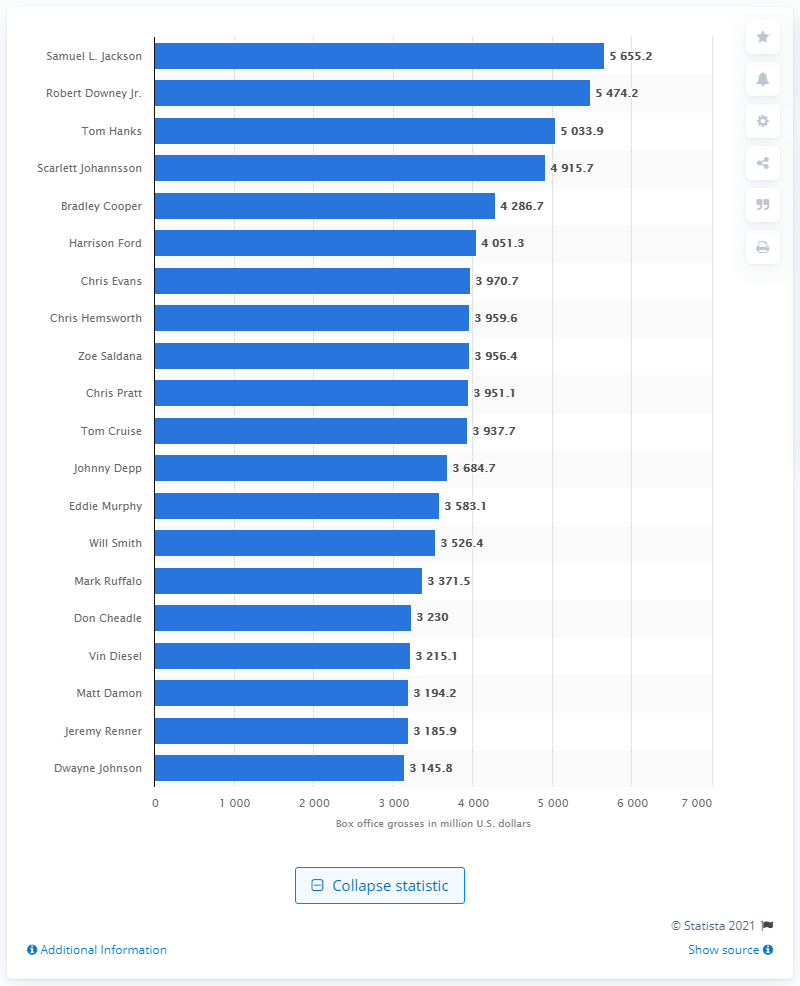Point out several critical features in this image. Samuel L. Jackson is the all-time highest-grossing actor in the United States and Canada. As of February 2021, the total box office revenue of Jackson was $56,552. 